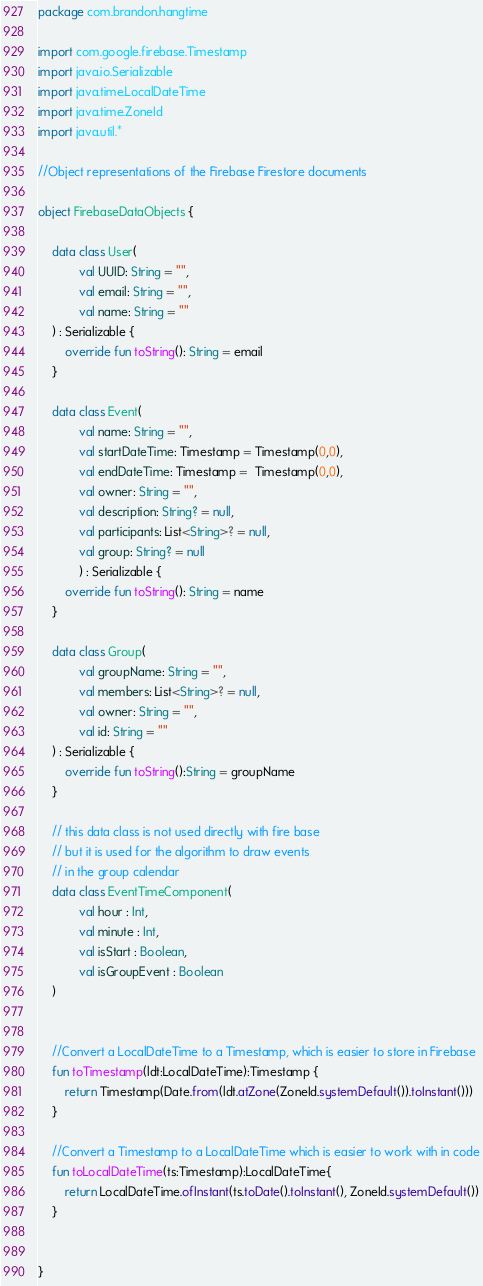Convert code to text. <code><loc_0><loc_0><loc_500><loc_500><_Kotlin_>package com.brandon.hangtime

import com.google.firebase.Timestamp
import java.io.Serializable
import java.time.LocalDateTime
import java.time.ZoneId
import java.util.*

//Object representations of the Firebase Firestore documents

object FirebaseDataObjects {

    data class User(
            val UUID: String = "",
            val email: String = "",
            val name: String = ""
    ) : Serializable {
        override fun toString(): String = email
    }

    data class Event(
            val name: String = "",
            val startDateTime: Timestamp = Timestamp(0,0),
            val endDateTime: Timestamp =  Timestamp(0,0),
            val owner: String = "",
            val description: String? = null,
            val participants: List<String>? = null,
            val group: String? = null
            ) : Serializable {
        override fun toString(): String = name
    }

    data class Group(
            val groupName: String = "",
            val members: List<String>? = null,
            val owner: String = "",
            val id: String = ""
    ) : Serializable {
        override fun toString():String = groupName
    }

    // this data class is not used directly with fire base
    // but it is used for the algorithm to draw events
    // in the group calendar
    data class EventTimeComponent(
            val hour : Int,
            val minute : Int,
            val isStart : Boolean,
            val isGroupEvent : Boolean
    )


    //Convert a LocalDateTime to a Timestamp, which is easier to store in Firebase
    fun toTimestamp(ldt:LocalDateTime):Timestamp {
        return Timestamp(Date.from(ldt.atZone(ZoneId.systemDefault()).toInstant()))
    }

    //Convert a Timestamp to a LocalDateTime which is easier to work with in code
    fun toLocalDateTime(ts:Timestamp):LocalDateTime{
        return LocalDateTime.ofInstant(ts.toDate().toInstant(), ZoneId.systemDefault())
    }


}</code> 